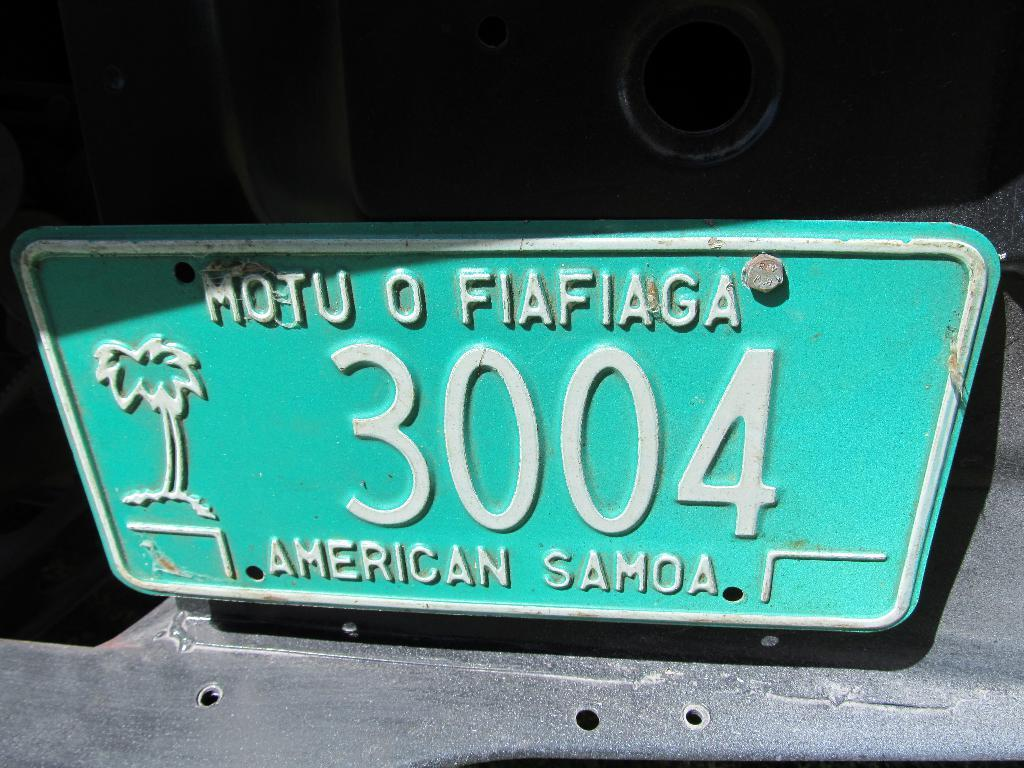<image>
Render a clear and concise summary of the photo. A faded green license plate for the island of American Samoa. 